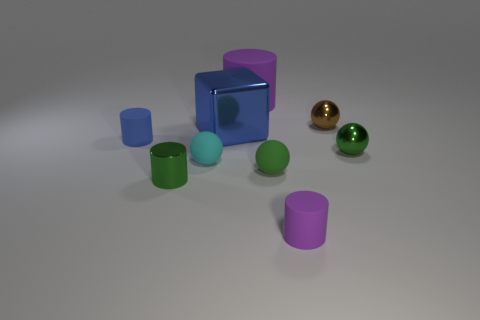Is the material of the large purple thing the same as the tiny green sphere right of the brown sphere?
Keep it short and to the point. No. There is a rubber cylinder that is in front of the tiny green metal object right of the green metallic object that is in front of the small green metal ball; what is its color?
Give a very brief answer. Purple. Are there any other things that are the same size as the blue metallic thing?
Your answer should be compact. Yes. Does the large cylinder have the same color as the ball behind the big shiny cube?
Keep it short and to the point. No. The big matte thing has what color?
Make the answer very short. Purple. There is a purple thing that is to the left of the small matte cylinder to the right of the tiny rubber cylinder behind the tiny green matte object; what shape is it?
Offer a very short reply. Cylinder. What number of other things are the same color as the tiny metal cylinder?
Your response must be concise. 2. Is the number of small blue things in front of the green shiny ball greater than the number of large objects in front of the big shiny object?
Provide a short and direct response. No. Are there any cyan objects to the left of the tiny cyan object?
Give a very brief answer. No. What material is the sphere that is right of the big cylinder and to the left of the brown shiny sphere?
Provide a succinct answer. Rubber. 